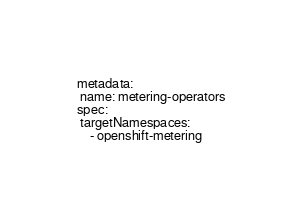Convert code to text. <code><loc_0><loc_0><loc_500><loc_500><_YAML_>metadata:
 name: metering-operators
spec:
 targetNamespaces:
    - openshift-metering

</code> 